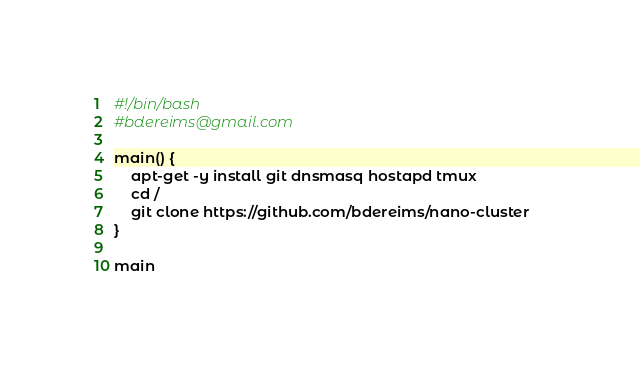Convert code to text. <code><loc_0><loc_0><loc_500><loc_500><_Bash_>#!/bin/bash
#bdereims@gmail.com

main() {
	apt-get -y install git dnsmasq hostapd tmux
	cd /
	git clone https://github.com/bdereims/nano-cluster	
}

main
</code> 